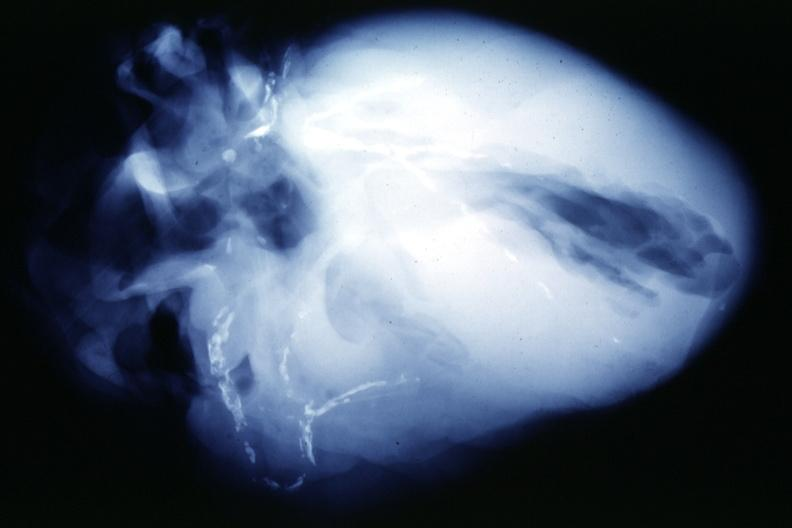what is present?
Answer the question using a single word or phrase. Vasculature 